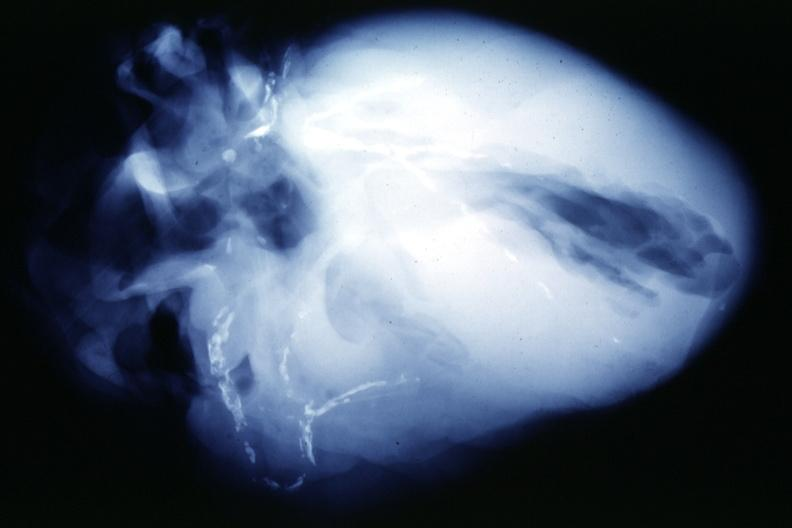what is present?
Answer the question using a single word or phrase. Vasculature 